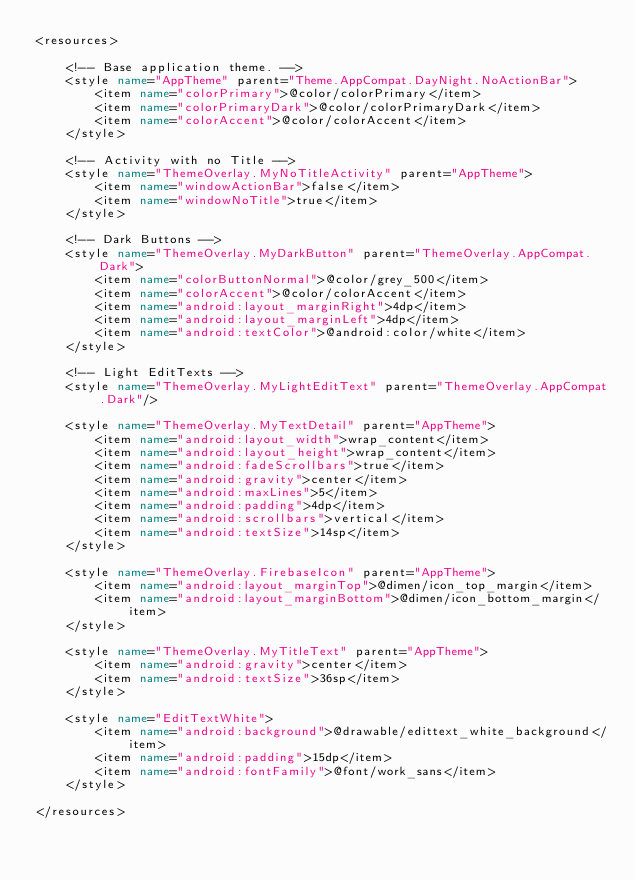Convert code to text. <code><loc_0><loc_0><loc_500><loc_500><_XML_><resources>

    <!-- Base application theme. -->
    <style name="AppTheme" parent="Theme.AppCompat.DayNight.NoActionBar">
        <item name="colorPrimary">@color/colorPrimary</item>
        <item name="colorPrimaryDark">@color/colorPrimaryDark</item>
        <item name="colorAccent">@color/colorAccent</item>
    </style>

    <!-- Activity with no Title -->
    <style name="ThemeOverlay.MyNoTitleActivity" parent="AppTheme">
        <item name="windowActionBar">false</item>
        <item name="windowNoTitle">true</item>
    </style>

    <!-- Dark Buttons -->
    <style name="ThemeOverlay.MyDarkButton" parent="ThemeOverlay.AppCompat.Dark">
        <item name="colorButtonNormal">@color/grey_500</item>
        <item name="colorAccent">@color/colorAccent</item>
        <item name="android:layout_marginRight">4dp</item>
        <item name="android:layout_marginLeft">4dp</item>
        <item name="android:textColor">@android:color/white</item>
    </style>

    <!-- Light EditTexts -->
    <style name="ThemeOverlay.MyLightEditText" parent="ThemeOverlay.AppCompat.Dark"/>

    <style name="ThemeOverlay.MyTextDetail" parent="AppTheme">
        <item name="android:layout_width">wrap_content</item>
        <item name="android:layout_height">wrap_content</item>
        <item name="android:fadeScrollbars">true</item>
        <item name="android:gravity">center</item>
        <item name="android:maxLines">5</item>
        <item name="android:padding">4dp</item>
        <item name="android:scrollbars">vertical</item>
        <item name="android:textSize">14sp</item>
    </style>

    <style name="ThemeOverlay.FirebaseIcon" parent="AppTheme">
        <item name="android:layout_marginTop">@dimen/icon_top_margin</item>
        <item name="android:layout_marginBottom">@dimen/icon_bottom_margin</item>
    </style>

    <style name="ThemeOverlay.MyTitleText" parent="AppTheme">
        <item name="android:gravity">center</item>
        <item name="android:textSize">36sp</item>
    </style>

    <style name="EditTextWhite">
        <item name="android:background">@drawable/edittext_white_background</item>
        <item name="android:padding">15dp</item>
        <item name="android:fontFamily">@font/work_sans</item>
    </style>

</resources></code> 